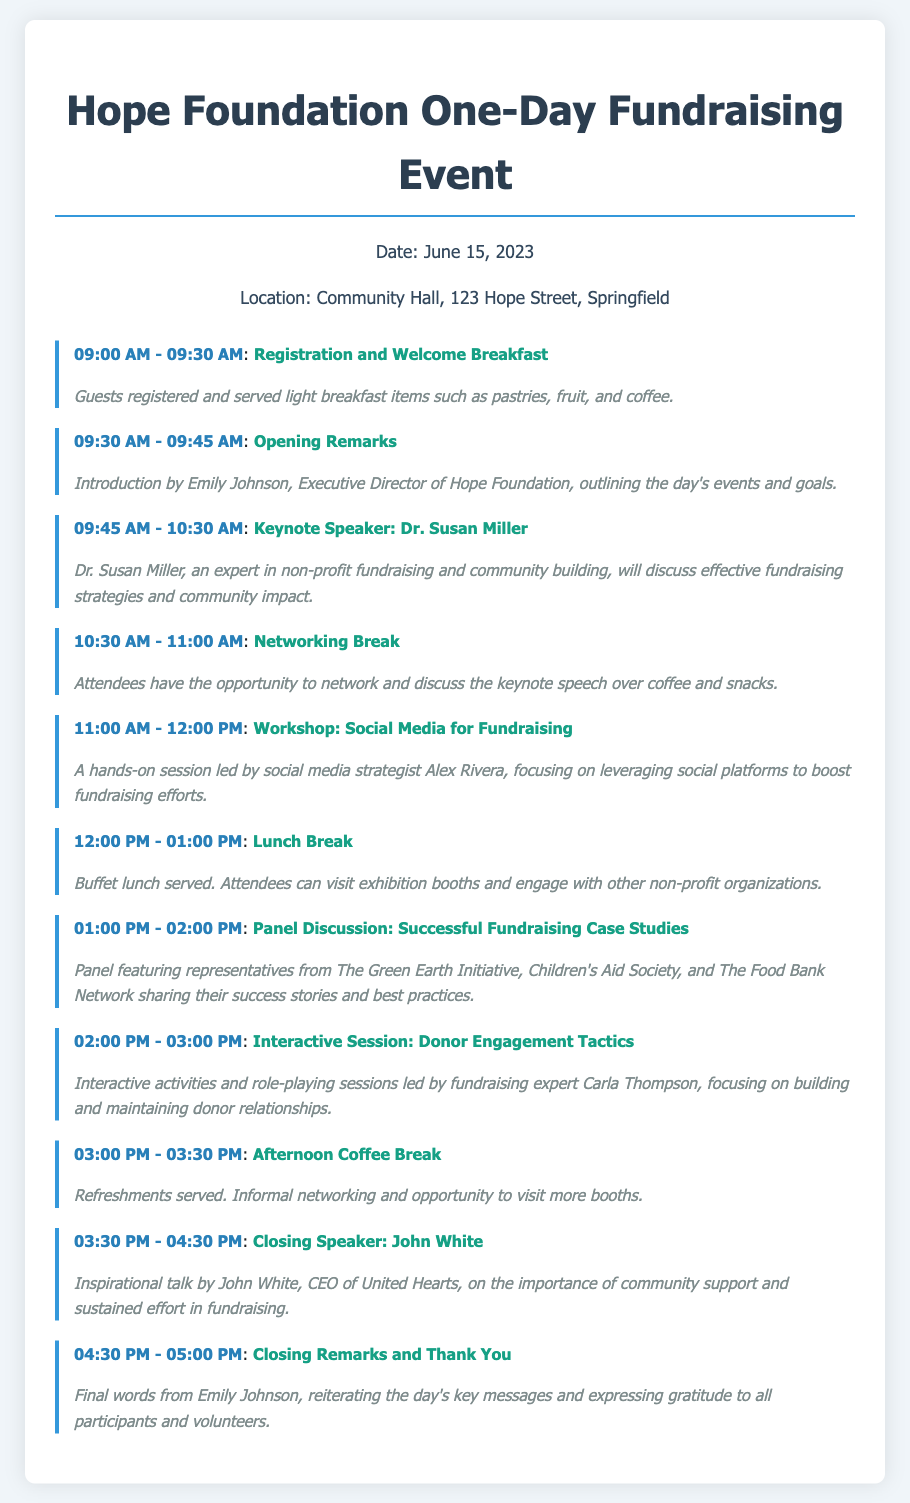What is the date of the event? The date is listed in the event information section of the document.
Answer: June 15, 2023 What is the location of the event? The location is specified right after the date in the event information section.
Answer: Community Hall, 123 Hope Street, Springfield Who is the keynote speaker? The keynote speaker's name and role are mentioned in the details of the session on keynote speech.
Answer: Dr. Susan Miller What time does the registration start? The registration and welcome breakfast time is the first listed time in the itinerary.
Answer: 09:00 AM What is the focus of the workshop led by Alex Rivera? The activity description provides insight into the topic of the workshop, which requires connecting information from the details.
Answer: Social Media for Fundraising How long is the networking break? The duration is noted in the timing of the networking session and the surrounding sessions.
Answer: 30 minutes How many speakers are there in total throughout the event? This requires counting from the itinerary sessions that mention speakers and panels.
Answer: 5 What type of meal is provided during the Lunch Break? The details of the lunch break session describe the meal type served.
Answer: Buffet lunch What is the last session of the day? By checking the order of sessions listed, we can find the final activity of the itinerary.
Answer: Closing Remarks and Thank You 